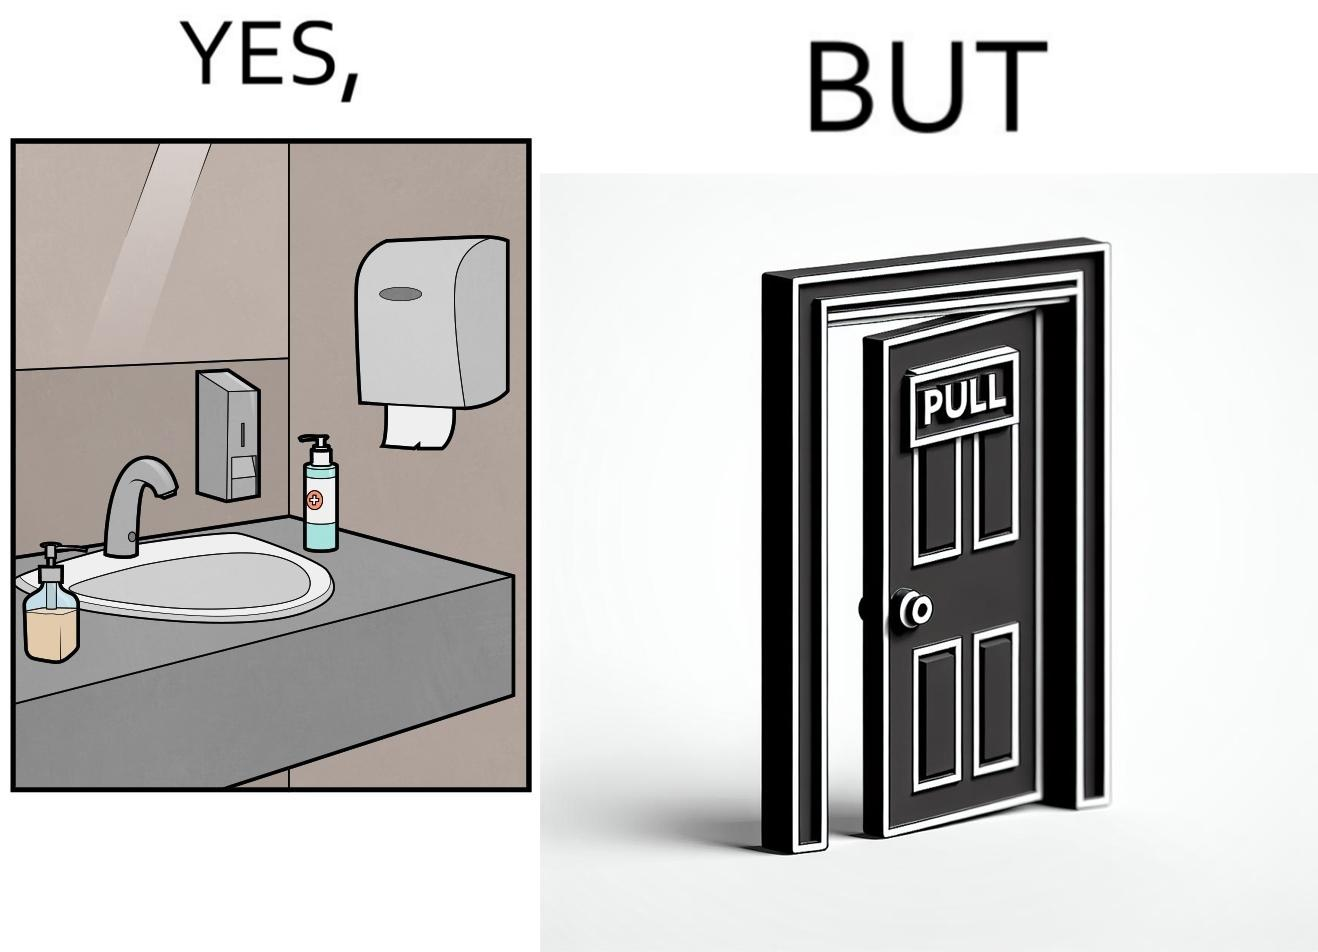What do you see in each half of this image? In the left part of the image: a basin with different handwashes and paper roll around it to clean hands with a mirror in front In the right part of the image: a door with a pull sign and handle on it 